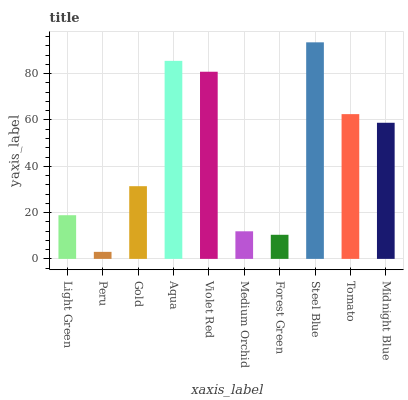Is Peru the minimum?
Answer yes or no. Yes. Is Steel Blue the maximum?
Answer yes or no. Yes. Is Gold the minimum?
Answer yes or no. No. Is Gold the maximum?
Answer yes or no. No. Is Gold greater than Peru?
Answer yes or no. Yes. Is Peru less than Gold?
Answer yes or no. Yes. Is Peru greater than Gold?
Answer yes or no. No. Is Gold less than Peru?
Answer yes or no. No. Is Midnight Blue the high median?
Answer yes or no. Yes. Is Gold the low median?
Answer yes or no. Yes. Is Peru the high median?
Answer yes or no. No. Is Light Green the low median?
Answer yes or no. No. 